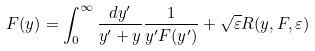Convert formula to latex. <formula><loc_0><loc_0><loc_500><loc_500>F ( y ) = \int _ { 0 } ^ { \infty } \frac { d y ^ { \prime } } { y ^ { \prime } + y } \frac { 1 } { y ^ { \prime } F ( y ^ { \prime } ) } + \sqrt { \varepsilon } R ( y , F , \varepsilon )</formula> 